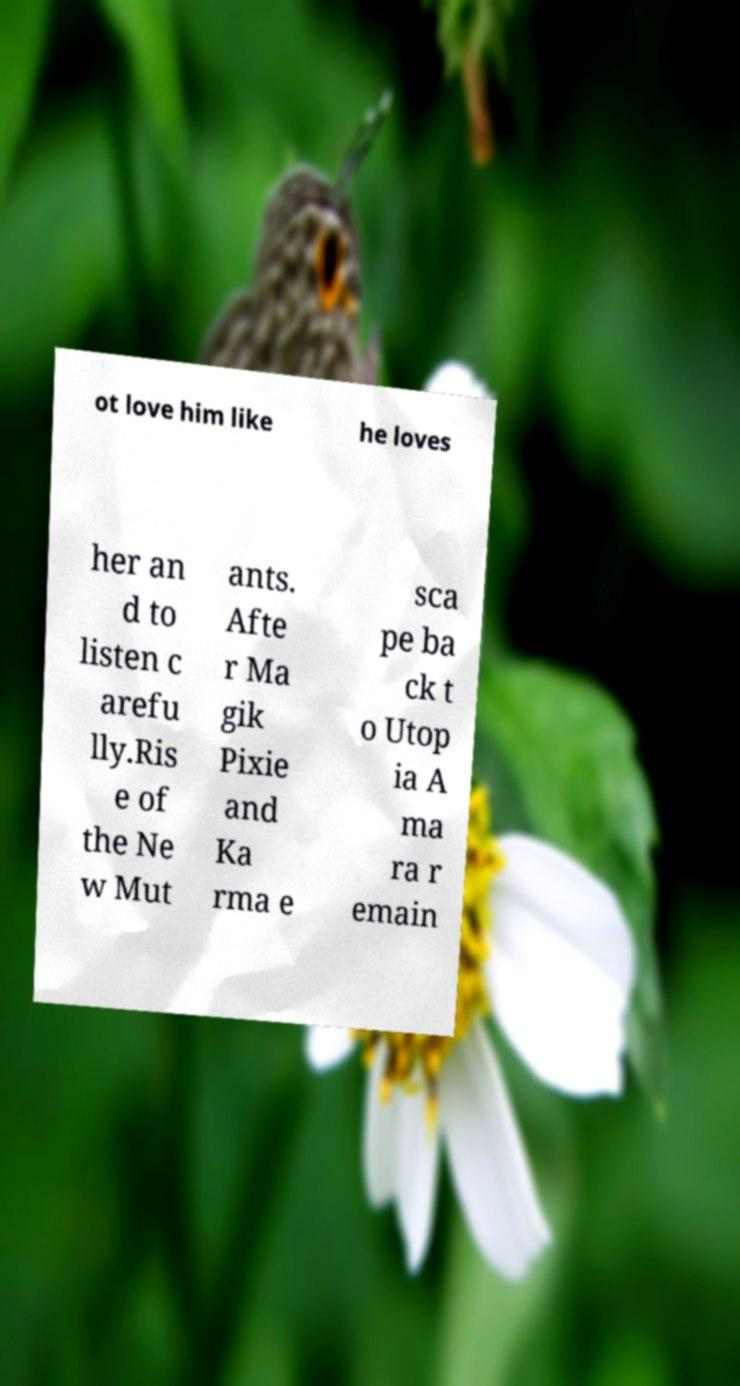What messages or text are displayed in this image? I need them in a readable, typed format. ot love him like he loves her an d to listen c arefu lly.Ris e of the Ne w Mut ants. Afte r Ma gik Pixie and Ka rma e sca pe ba ck t o Utop ia A ma ra r emain 